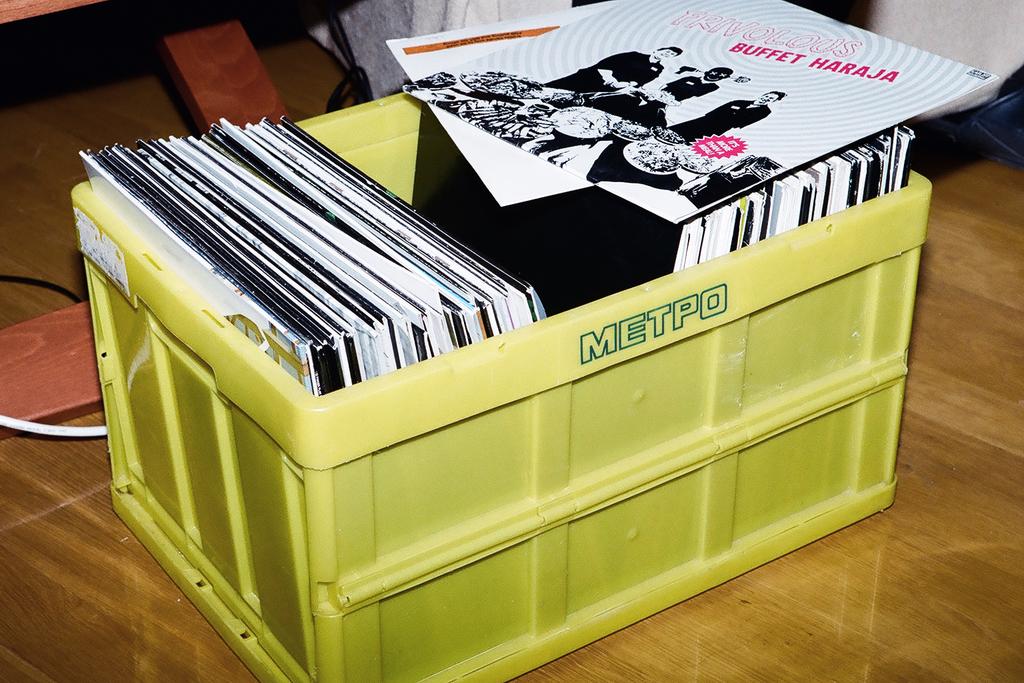Which record is that?
Provide a short and direct response. Buffet haraja. Whatsthename on thebox?
Offer a very short reply. Metpo. 